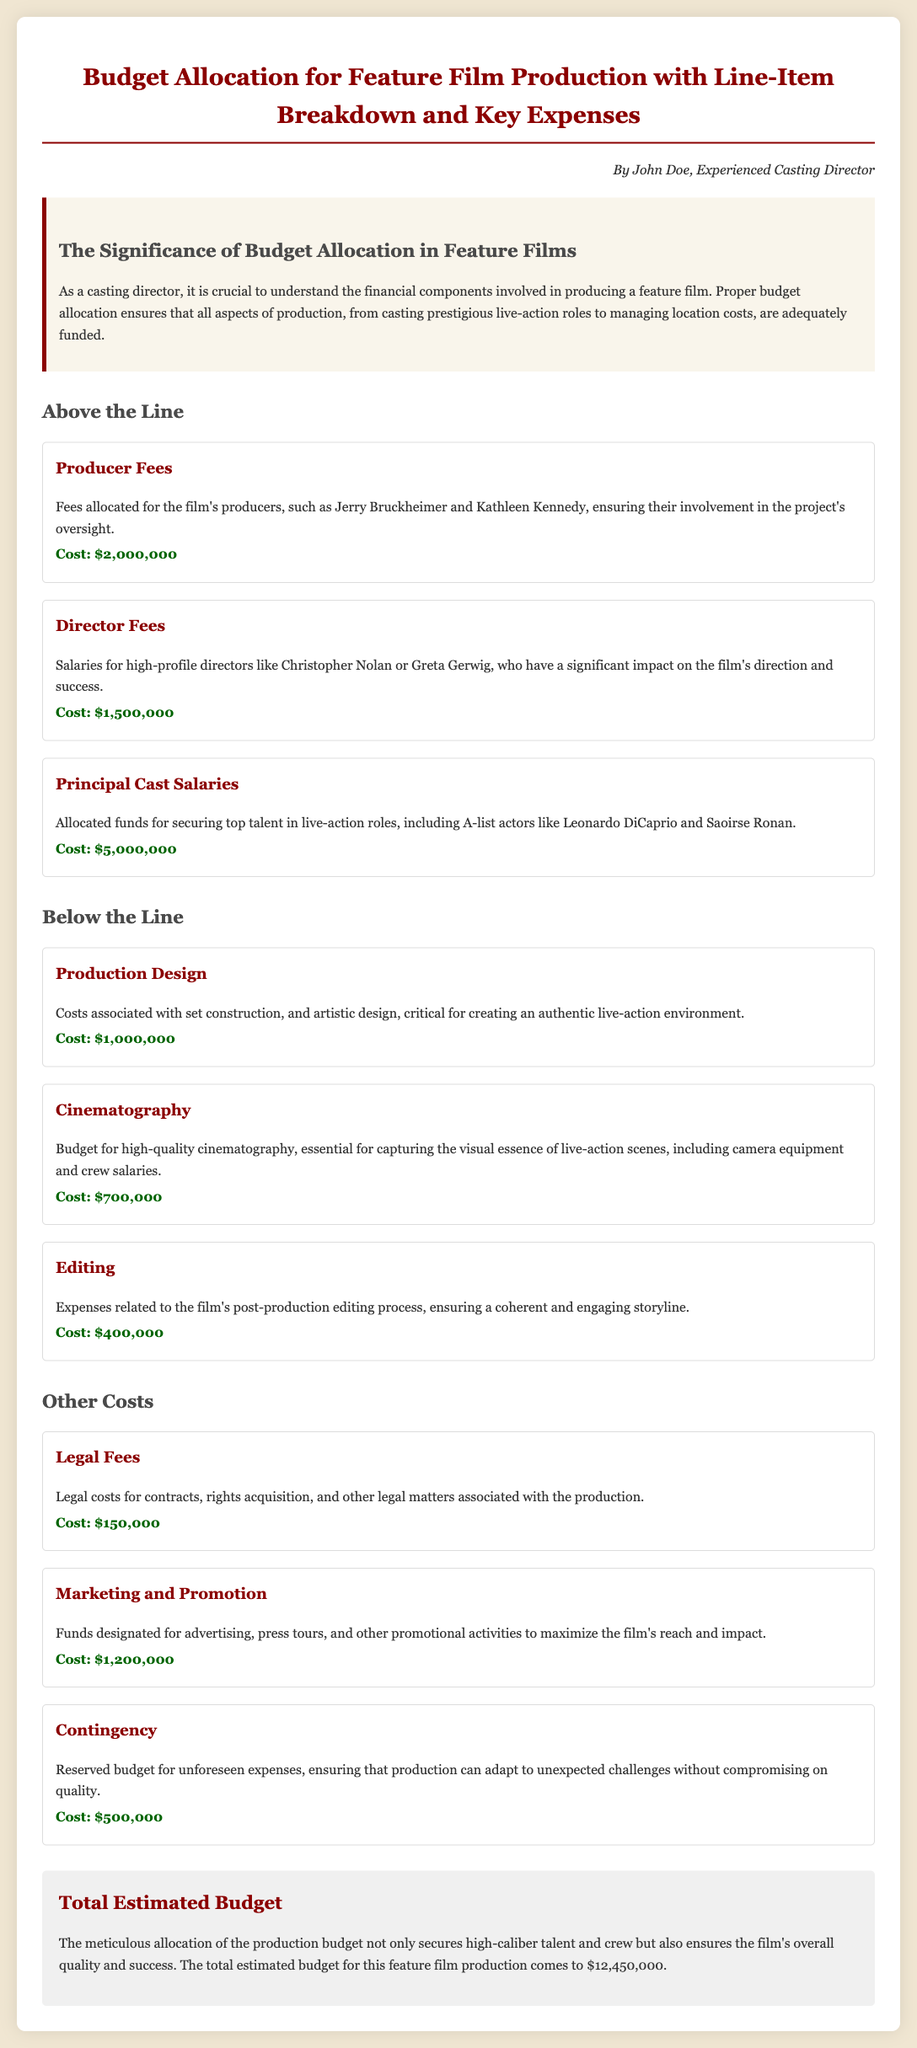What is the total estimated budget? The total estimated budget is stated in the summary section of the document.
Answer: $12,450,000 What is the cost of Principal Cast Salaries? The cost mentioned for Principal Cast Salaries is provided in the Above the Line section.
Answer: $5,000,000 Who are two notable producers mentioned? The document lists specific influential producers in the cost allocation section.
Answer: Jerry Bruckheimer, Kathleen Kennedy How much is allocated for Marketing and Promotion? This cost is listed under the Other Costs section in the document.
Answer: $1,200,000 What is the cost allocated for Editing? The expenses related to Editing are clearly stated in the Below the Line section.
Answer: $400,000 What is the purpose of the Contingency fund? It describes a reserved budget for unexpected challenges in the production.
Answer: Unforeseen expenses How much is allocated for Cinematography? The document provides a clear line-item breakdown for this specific cost.
Answer: $700,000 What are the two components listed under Above the Line expenses? The question relates to key headings in the document that describe budget allocation.
Answer: Producer Fees, Director Fees Which expense category has the highest allocation? The highest allocated expense can be determined from the line-item costs listed.
Answer: Principal Cast Salaries 